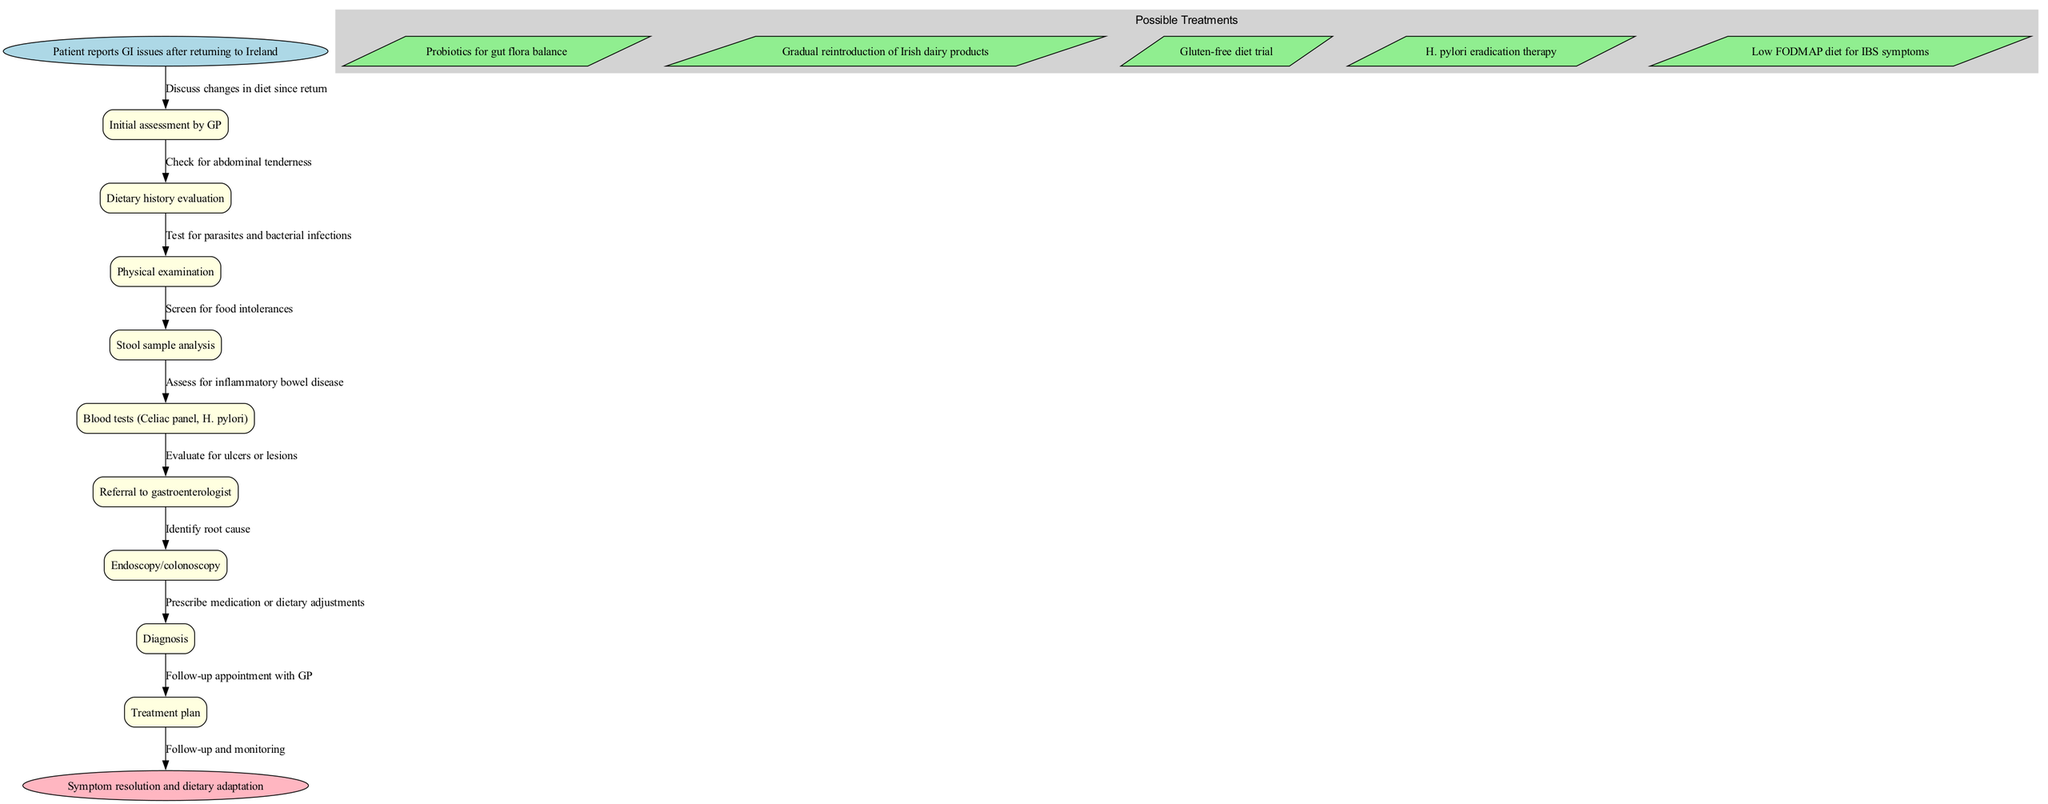What is the first step in the clinical pathway? The first step, as indicated by the start node in the diagram, is "Patient reports GI issues after returning to Ireland." This is explicitly mentioned as the initiating event of the clinical pathway.
Answer: Patient reports GI issues after returning to Ireland How many treatment options are listed in the diagram? The diagram has a subgraph labeled "Possible Treatments," which contains a total of five treatments. Thus, the answer is found by counting the treatment nodes within that cluster.
Answer: 5 What node follows “Physical examination”? The direct edge connecting "Physical examination" indicates the next node in the sequence is "Stool sample analysis." This can be identified by reviewing the flow of edges leading from one node to the next.
Answer: Stool sample analysis What is assessed after "Blood tests (Celiac panel, H. pylori)"? Following the "Blood tests" node, the next step according to the edge connections leads to "Referral to gastroenterologist." Hence, this can be observed by tracking the sequence of nodes.
Answer: Referral to gastroenterologist What happens after the "Diagnosis" node? The edge leading from "Diagnosis" to "Treatment plan" shows that treatment planning is the next action taken after diagnosis in the clinical pathway. This is a direct observation from the diagram's flow.
Answer: Treatment plan What is the last step in the clinical pathway? The final node indicated in the diagram is "Symptom resolution and dietary adaptation," which is linked to the last processing step, confirming it ends the pathway.
Answer: Symptom resolution and dietary adaptation Which diagnostic tests are conducted after the initial assessment? After the "Initial assessment by GP" node, the pathway indicates that two main diagnostic tests ("Blood tests (Celiac panel, H. pylori)" and "Stool sample analysis") are conducted. Thus, these two steps follow the initial assessment directly.
Answer: Blood tests (Celiac panel, H. pylori), Stool sample analysis Which treatment involves dietary adjustments? The specific treatment option that involves dietary adjustments is "Gradual reintroduction of Irish dairy products." This is explicitly mentioned as one of the treatments in the diagram focused on dietary changes.
Answer: Gradual reintroduction of Irish dairy products What relationships can be made between diagnostic and treatment nodes? The relationship exists where diagnostic results lead to specific treatments; for instance, if the diagnosis identifies a food intolerance, the appropriate treatment would be a "Gluten-free diet trial." This requires analyzing the pathway to understand how outcomes influence treatment decisions.
Answer: Diagnosis influences treatment decisions 